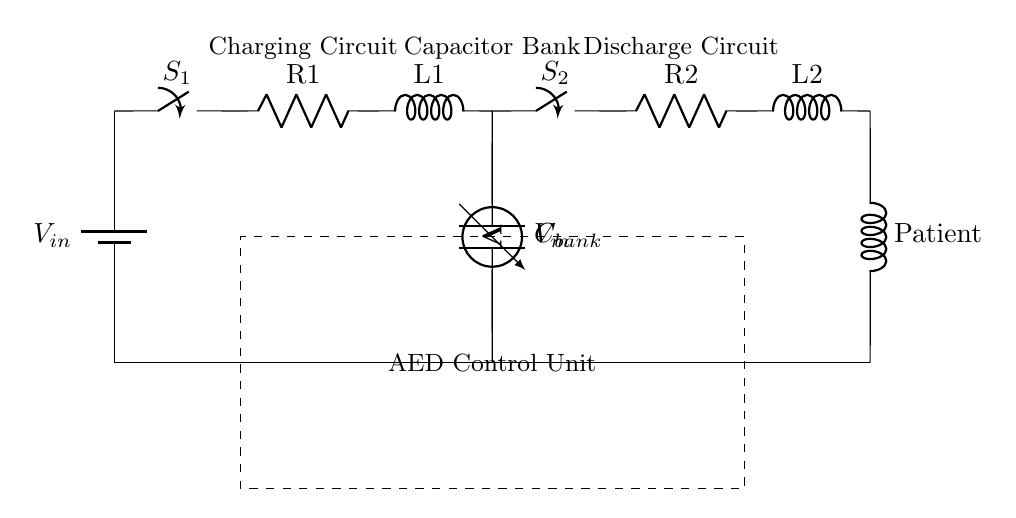What component stores charge in the circuit? The component that stores charge is a capacitor. In the circuit diagram, the capacitor is labeled as C_bank, and it is directly connected in parallel with the discharge path.
Answer: Capacitor What is the role of switch S1? Switch S1 controls the charging circuit; when closed, it connects the power source to the capacitor bank for charging. Thus, its function is to allow or disconnect the flow of current to the capacitor.
Answer: Charging control What is the purpose of the control unit in this circuit? The control unit (highlighted by the dashed rectangle) manages the operation of the entire AED system, especially the timing of charging and discharging the capacitor bank to deliver shocks as needed.
Answer: Circuit management What happens when switch S2 is closed? When switch S2 is closed, the stored energy in the capacitor bank is allowed to discharge through the resistance and inductance towards the patient. This delivers a shock to assist in restoring normal heart rhythm.
Answer: Energy discharge How does the circuit ensure the patient receives treatment only when intended? The circuit employs switches S1 and S2, allowing active control over the charging and discharging process. By managing these switches, the circuit guarantees that shocks are delivered at appropriate times, avoiding accidental discharge.
Answer: Controlled delivery What is connected to the output side of the capacitor bank? The output side of the capacitor bank is connected to switch S2, which controls the flow of energy to the load (the patient). This setup ensures that the energy is only released when the circuit is activated by involving switch S2.
Answer: Switch S2 